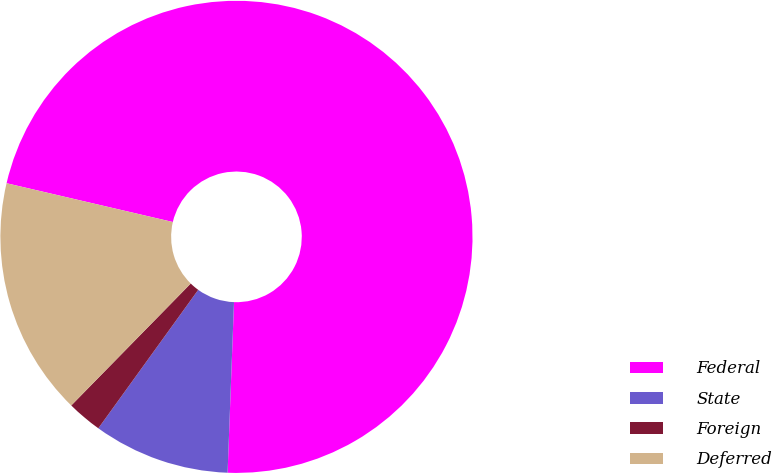Convert chart to OTSL. <chart><loc_0><loc_0><loc_500><loc_500><pie_chart><fcel>Federal<fcel>State<fcel>Foreign<fcel>Deferred<nl><fcel>71.95%<fcel>9.35%<fcel>2.39%<fcel>16.31%<nl></chart> 